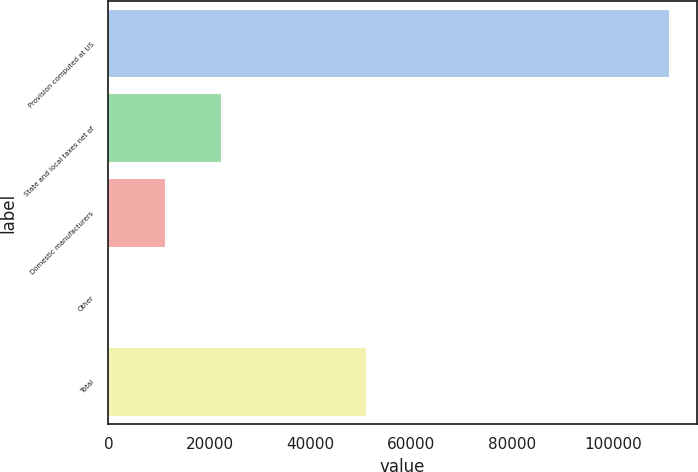Convert chart to OTSL. <chart><loc_0><loc_0><loc_500><loc_500><bar_chart><fcel>Provision computed at US<fcel>State and local taxes net of<fcel>Domestic manufacturers<fcel>Other<fcel>Total<nl><fcel>110939<fcel>22347.8<fcel>11273.9<fcel>200<fcel>51076<nl></chart> 